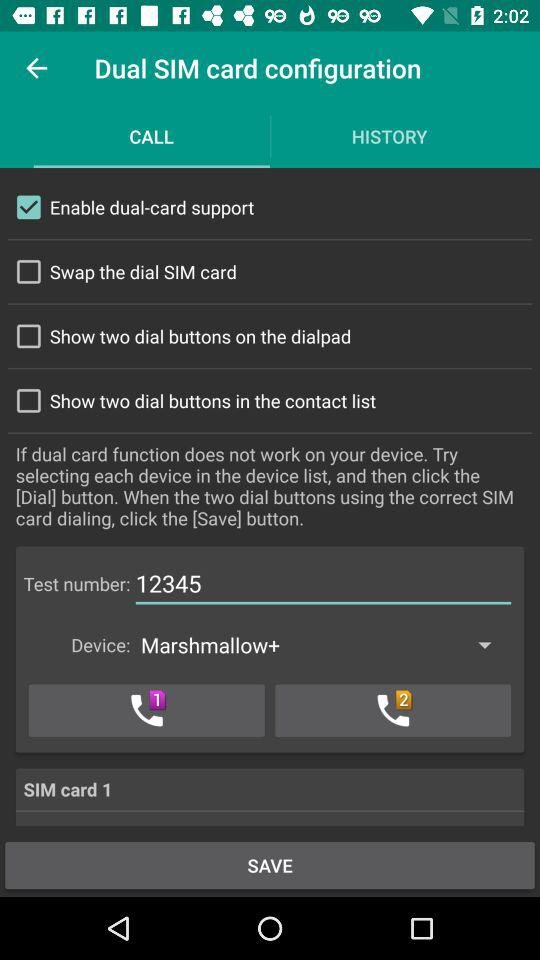Which option is selected? The selected option is "Enable dual-card support". 